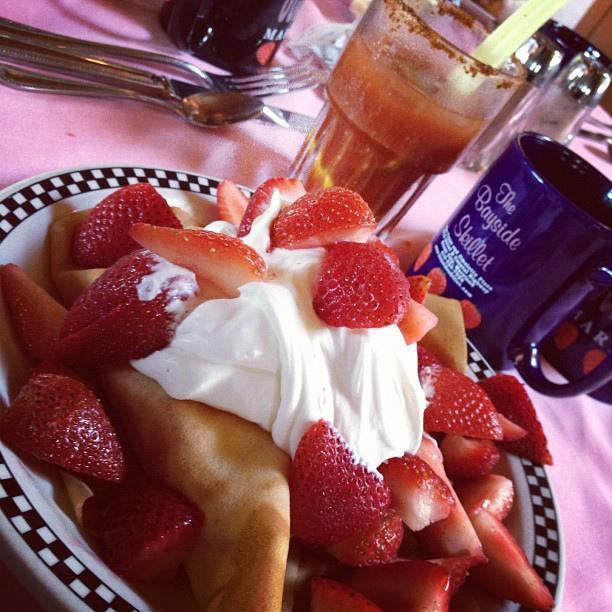How many cups are there?
Give a very brief answer. 3. 